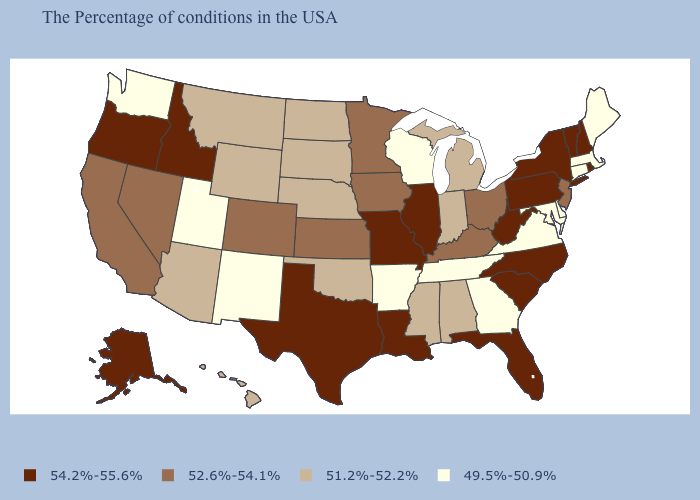Name the states that have a value in the range 51.2%-52.2%?
Quick response, please. Michigan, Indiana, Alabama, Mississippi, Nebraska, Oklahoma, South Dakota, North Dakota, Wyoming, Montana, Arizona, Hawaii. Does Indiana have a lower value than Idaho?
Answer briefly. Yes. What is the value of New Mexico?
Quick response, please. 49.5%-50.9%. Name the states that have a value in the range 49.5%-50.9%?
Answer briefly. Maine, Massachusetts, Connecticut, Delaware, Maryland, Virginia, Georgia, Tennessee, Wisconsin, Arkansas, New Mexico, Utah, Washington. What is the lowest value in states that border Texas?
Give a very brief answer. 49.5%-50.9%. Which states have the lowest value in the South?
Quick response, please. Delaware, Maryland, Virginia, Georgia, Tennessee, Arkansas. Among the states that border Mississippi , does Arkansas have the lowest value?
Be succinct. Yes. Does Wisconsin have the lowest value in the MidWest?
Be succinct. Yes. Which states hav the highest value in the MidWest?
Write a very short answer. Illinois, Missouri. Name the states that have a value in the range 54.2%-55.6%?
Answer briefly. Rhode Island, New Hampshire, Vermont, New York, Pennsylvania, North Carolina, South Carolina, West Virginia, Florida, Illinois, Louisiana, Missouri, Texas, Idaho, Oregon, Alaska. What is the value of Idaho?
Write a very short answer. 54.2%-55.6%. Does Hawaii have the highest value in the West?
Answer briefly. No. What is the value of Vermont?
Quick response, please. 54.2%-55.6%. Does Delaware have the highest value in the South?
Be succinct. No. Does the map have missing data?
Write a very short answer. No. 